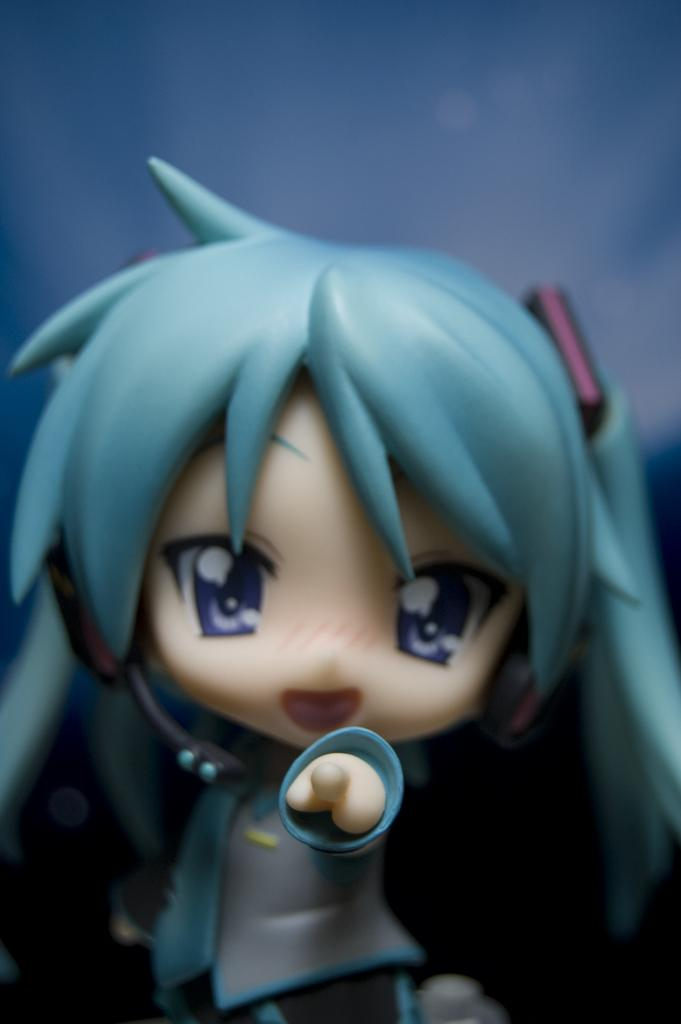What type of doll is in the picture? There is a girl doll in the picture. What is a distinctive feature of the girl doll? The girl doll has blue hair. What color is the background in the picture? The background in the picture is blue. How many ducks are swimming in the blue soda in the picture? There are no ducks or soda present in the image; it features a girl doll with blue hair against a blue background. 